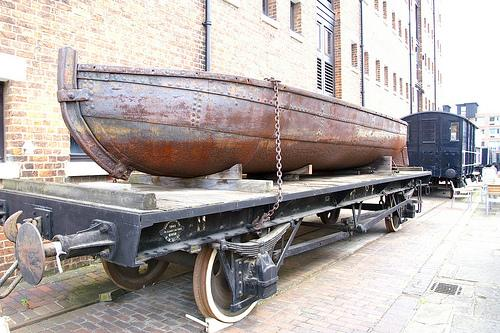Identify the material of the wall and its color. The wall is made of brick and is red in color. How many windows are visible in the train car? There are windows in the train car, but the bounding box information does not provide an exact count of the windows. Provide a brief description of the overall scene captured in the image. The image shows an old brown boat tied to a train cart on a rail track, surrounded by a red brick building, a pavement, and various pipes on the wall. Briefly describe the train car's appearance and its location relative to the other objects. The train car is an old black train car on the track, located near a red brick building and tied to a rusty boat. What is the primary color of the boat and its overall condition? The boat is brown in color and is in an old, rusty, and possibly haunted condition. Explain how the boat is attached to other objects in the image. The boat is tied to the train cart using a heavy chain and metal bolts. Describe the object that seems dominating in the image and its relation with other objects around. A large brown boat dominates the image, which is tied to a train cart and has heavy chains on it, as well as metal bolts. What are the various pipes in the image composed of and what are their colors? The image has black colored storm drain pipes and black drain pipes on the wall, and there are pipe lines attached to the red brick wall as well. Which objects in the image suggest that it's likely daylight? The white-colored sky suggests that the picture is taken during the daytime. What unique features can be found on the ground or the floor in the image? The ground has a brown-colored floor, a drain attached to it, and a shadow falls on it as well. What sort of item is hitched to a trailer? A wheel Can you see any trees in the image? There is no mention of trees or any other type of vegetation in the given image information. What creepy feature is associated with the large boat? It is possibly haunted In the image, what is the appearance of the pipe lines that are attached to the wall? The pipes are black-colored What would you describe happening between the boat and the cart in the given image? The boat is tied to the cart Which object best matches the description: a large, old, and possibly haunted boat? The large brown boat at X:45 Y:41 Is the old black train car near another object? If so, what is it? Yes, it is near a large red brick building Is there a person sitting at the table and chairs? There is no mention of a person in any of the image information. Only table and chairs are described. Identify an object that is both black and cylindrical. A black drain pipe on the wall Is the sky clear, cloudy, or white? The sky is white color Describe the color and material of the wall near the window at X:343 Y:8. The wall is made of red bricks Can you find the green train car in the image? The train car mentioned in the image information is described as old and black, not green. What is the large object occupying most of the image? A large brown boat Multiple-choice: What object can be found on the ground - a drain, a window or a wagon wheel? A drain Which item is near the meshed sewer cover and on ground level? A vent in the sidewalk What is the appearance of the ground where a shadow falls? The ground is brown colored Observe the windows in the train car. Are they attached to a wall? Yes, the windows are attached to the wall Is the boat floating on water in the image? There is no mention of water in the given image information. The boat is mentioned to be tied to a train cart and on the ground. Identify an unusual item found in the picture's platform. A black and white sticker Can you pinpoint the location of the tall multi-story building? At X:434 Y:93 Is the sky blue in the image? The sky is described as white color in the given image information, not blue. Are the windows in the train car made of wood? There is no information about the material of the windows. They are only described as being attached to the train car. What are the metal bolts doing on the boat? They are attaching or securing parts of the boat Which object in the image is made of metal and shaped like a disk? A metal disk attachment at X:13 Y:222 Is the train on the track or off? The train is on the track 